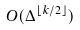Convert formula to latex. <formula><loc_0><loc_0><loc_500><loc_500>O ( \Delta ^ { \lfloor k / 2 \rfloor } )</formula> 